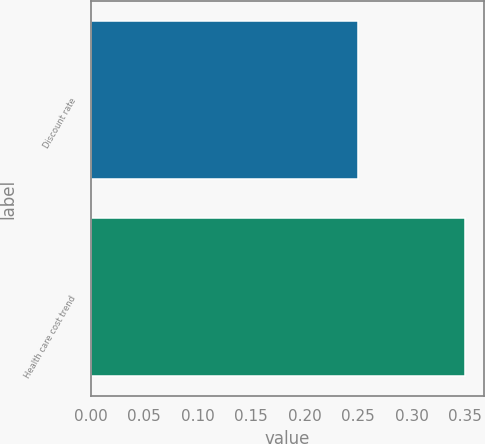Convert chart. <chart><loc_0><loc_0><loc_500><loc_500><bar_chart><fcel>Discount rate<fcel>Health care cost trend<nl><fcel>0.25<fcel>0.35<nl></chart> 